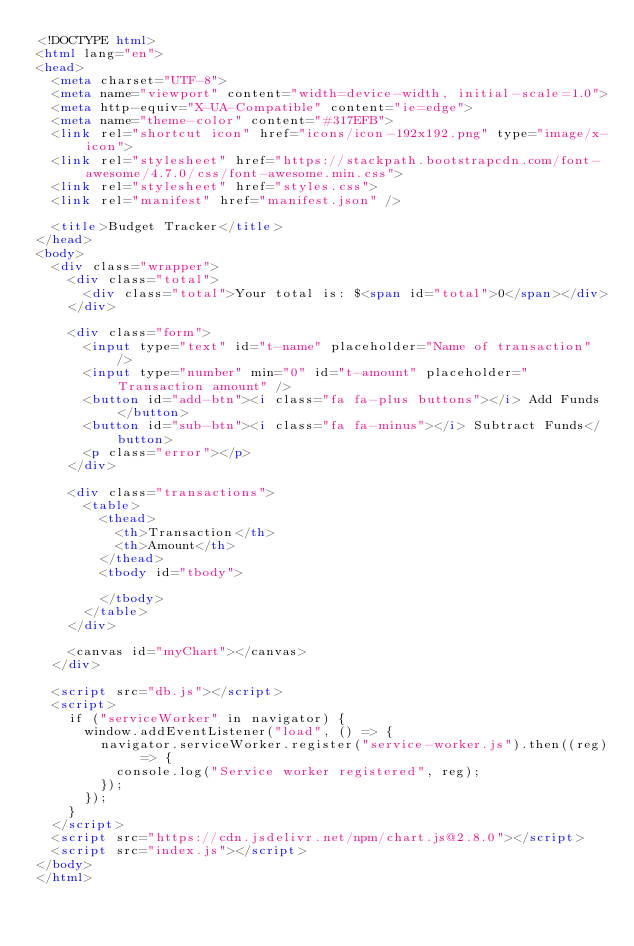<code> <loc_0><loc_0><loc_500><loc_500><_HTML_><!DOCTYPE html>
<html lang="en">
<head>
  <meta charset="UTF-8">
  <meta name="viewport" content="width=device-width, initial-scale=1.0">
  <meta http-equiv="X-UA-Compatible" content="ie=edge">
  <meta name="theme-color" content="#317EFB">
  <link rel="shortcut icon" href="icons/icon-192x192.png" type="image/x-icon">
  <link rel="stylesheet" href="https://stackpath.bootstrapcdn.com/font-awesome/4.7.0/css/font-awesome.min.css">
  <link rel="stylesheet" href="styles.css">
  <link rel="manifest" href="manifest.json" />

  <title>Budget Tracker</title>
</head>
<body>
  <div class="wrapper">
    <div class="total">
      <div class="total">Your total is: $<span id="total">0</span></div>
    </div>

    <div class="form">
      <input type="text" id="t-name" placeholder="Name of transaction" />
      <input type="number" min="0" id="t-amount" placeholder="Transaction amount" />
      <button id="add-btn"><i class="fa fa-plus buttons"></i> Add Funds</button>
      <button id="sub-btn"><i class="fa fa-minus"></i> Subtract Funds</button>
      <p class="error"></p>
    </div>

    <div class="transactions">
      <table>
        <thead>
          <th>Transaction</th>
          <th>Amount</th>
        </thead>
        <tbody id="tbody">
          
        </tbody>
      </table>
    </div>
    
    <canvas id="myChart"></canvas>
  </div>

  <script src="db.js"></script>
  <script>
    if ("serviceWorker" in navigator) {
      window.addEventListener("load", () => {
        navigator.serviceWorker.register("service-worker.js").then((reg) => {
          console.log("Service worker registered", reg);
        });
      });
    }
  </script>
  <script src="https://cdn.jsdelivr.net/npm/chart.js@2.8.0"></script>
  <script src="index.js"></script>
</body>
</html></code> 